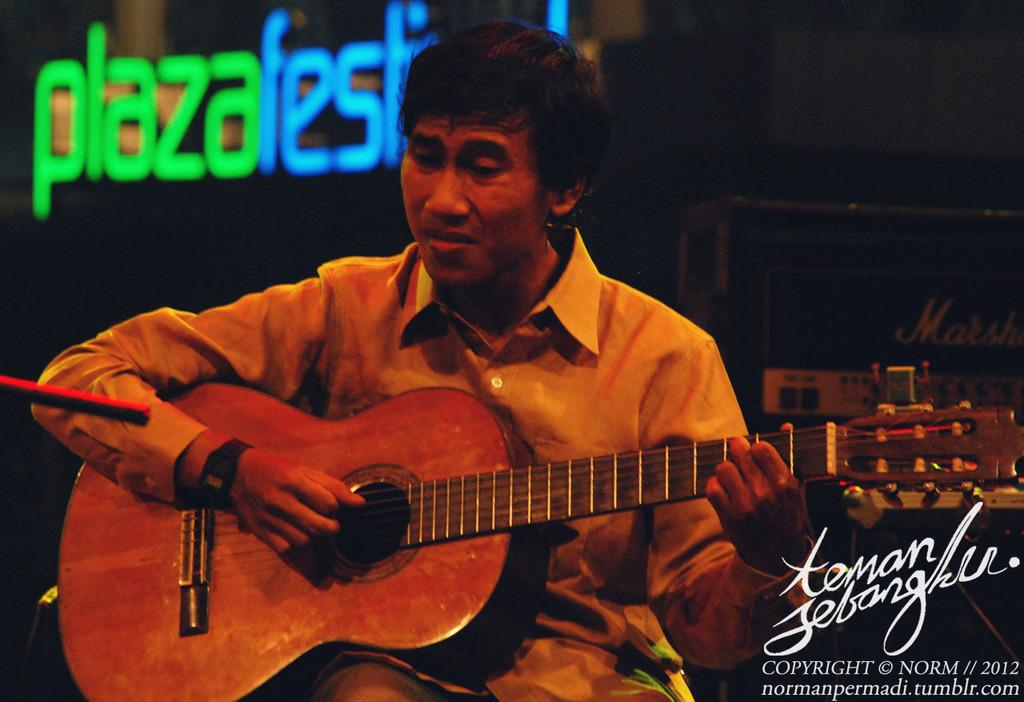What is the main subject of the image? There is a person in the image. What is the person doing in the image? The person is sitting and playing a guitar. What can be observed about the person's attire in the image? The person is wearing clothes and a watch. What type of leaf can be seen falling from the guitar in the image? There is no leaf present in the image, nor is there any indication of a leaf falling from the guitar. 